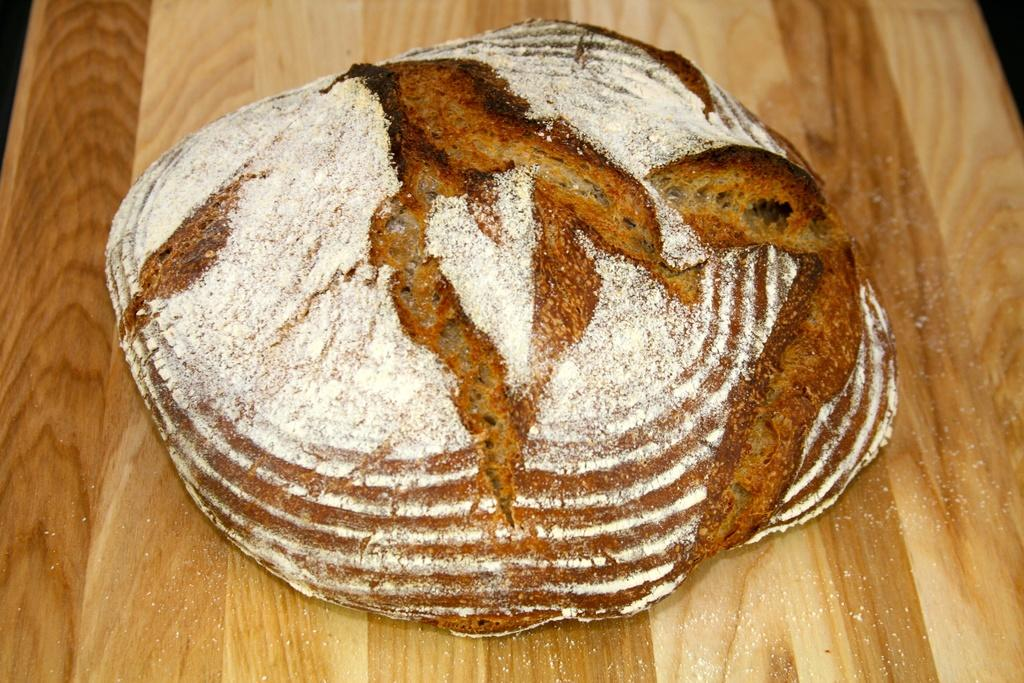What type of surface is visible in the image? There is a wooden surface in the image. What is on top of the wooden surface? There is food on the wooden surface. What type of mask is being used to prepare the food on the wooden surface? There is no mask present in the image, and the food preparation is not mentioned in the provided facts. 